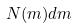<formula> <loc_0><loc_0><loc_500><loc_500>N ( m ) d m</formula> 